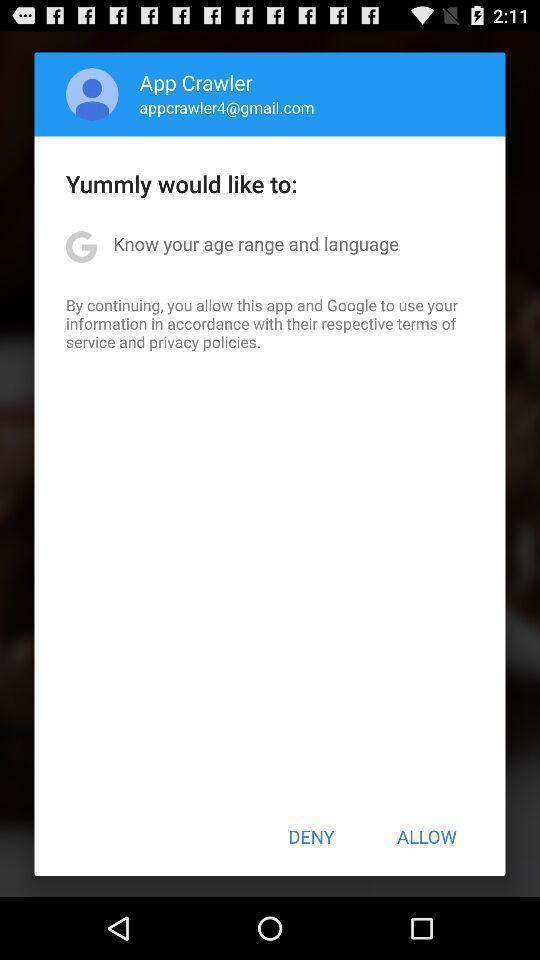Summarize the information in this screenshot. Popup showing options to select. 